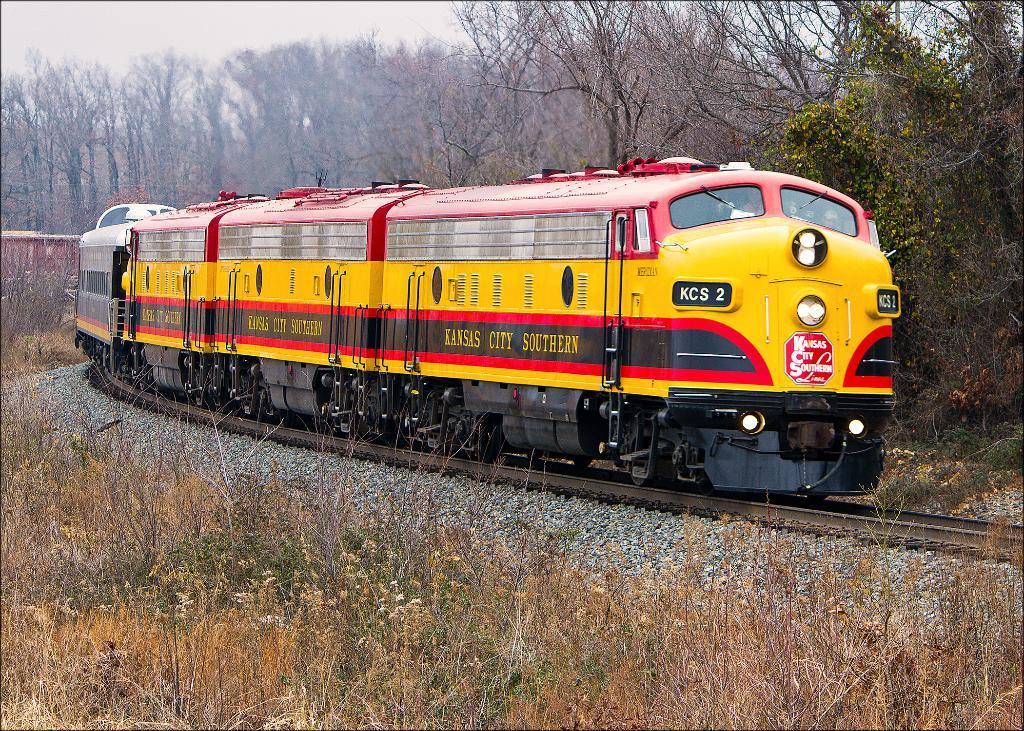Could you give a brief overview of what you see in this image? There is a train on a railway track. On the train there is something written. Near to the railway track there are stones and grasses. In the background there are trees. 